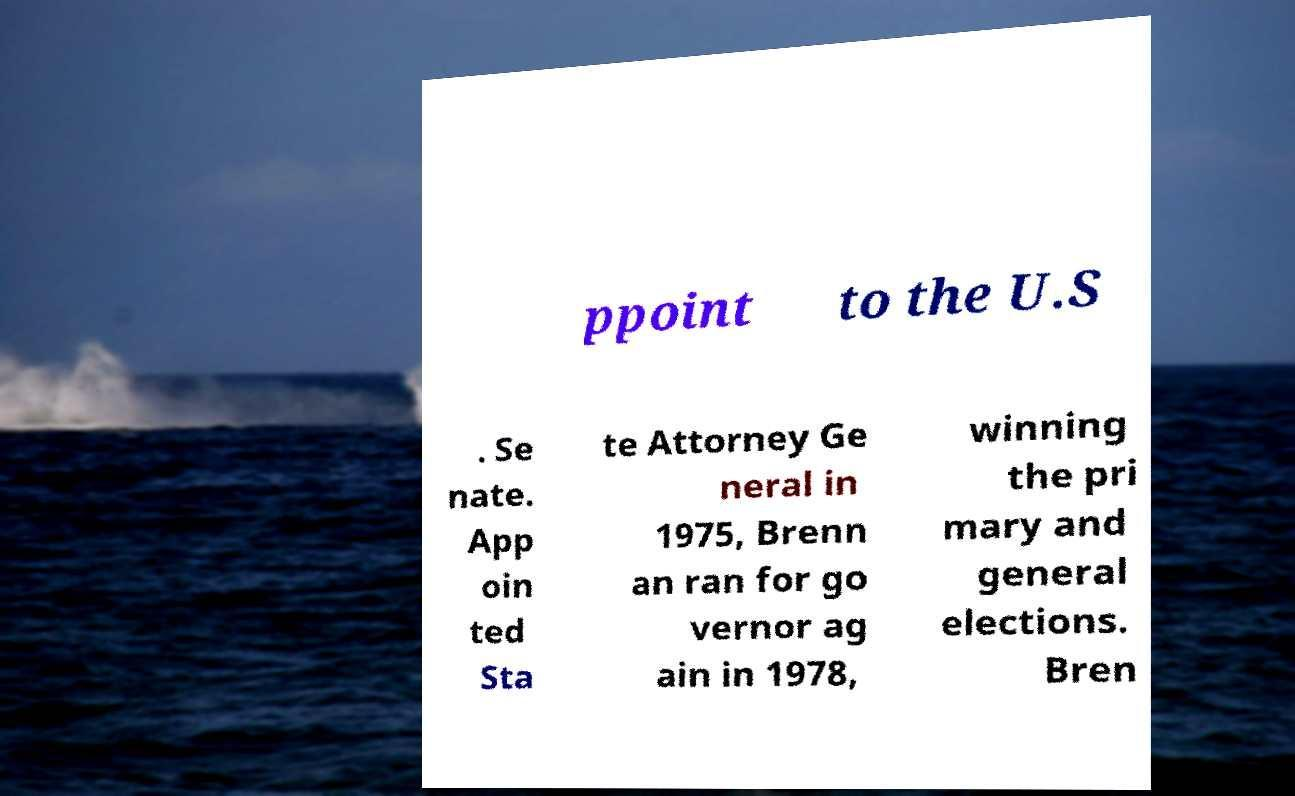Can you accurately transcribe the text from the provided image for me? ppoint to the U.S . Se nate. App oin ted Sta te Attorney Ge neral in 1975, Brenn an ran for go vernor ag ain in 1978, winning the pri mary and general elections. Bren 